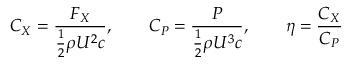Convert formula to latex. <formula><loc_0><loc_0><loc_500><loc_500>C _ { X } = \frac { F _ { X } } { \frac { 1 } { 2 } \rho U ^ { 2 } c } , \quad C _ { P } = \frac { P } { \frac { 1 } { 2 } \rho U ^ { 3 } c } , \quad \eta = \frac { C _ { X } } { C _ { P } }</formula> 